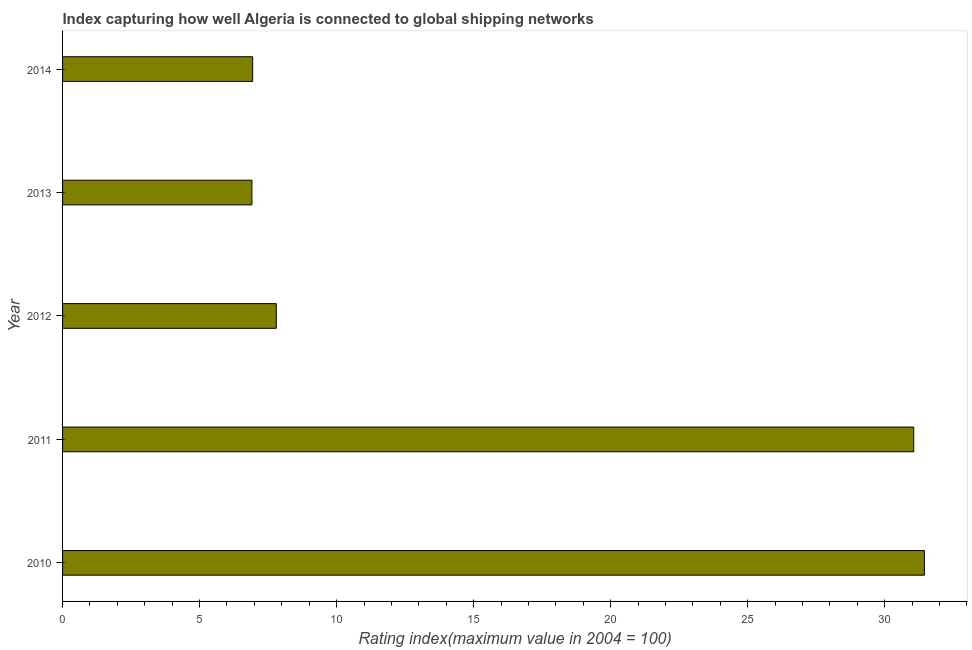Does the graph contain grids?
Your answer should be compact. No. What is the title of the graph?
Keep it short and to the point. Index capturing how well Algeria is connected to global shipping networks. What is the label or title of the X-axis?
Provide a short and direct response. Rating index(maximum value in 2004 = 100). What is the label or title of the Y-axis?
Your answer should be very brief. Year. What is the liner shipping connectivity index in 2011?
Ensure brevity in your answer.  31.06. Across all years, what is the maximum liner shipping connectivity index?
Provide a succinct answer. 31.45. Across all years, what is the minimum liner shipping connectivity index?
Give a very brief answer. 6.91. In which year was the liner shipping connectivity index minimum?
Your response must be concise. 2013. What is the sum of the liner shipping connectivity index?
Provide a short and direct response. 84.16. What is the difference between the liner shipping connectivity index in 2012 and 2013?
Your answer should be compact. 0.89. What is the average liner shipping connectivity index per year?
Your answer should be compact. 16.83. In how many years, is the liner shipping connectivity index greater than 30 ?
Offer a very short reply. 2. What is the ratio of the liner shipping connectivity index in 2012 to that in 2013?
Ensure brevity in your answer.  1.13. What is the difference between the highest and the second highest liner shipping connectivity index?
Keep it short and to the point. 0.39. Is the sum of the liner shipping connectivity index in 2012 and 2013 greater than the maximum liner shipping connectivity index across all years?
Provide a succinct answer. No. What is the difference between the highest and the lowest liner shipping connectivity index?
Your response must be concise. 24.54. In how many years, is the liner shipping connectivity index greater than the average liner shipping connectivity index taken over all years?
Ensure brevity in your answer.  2. How many bars are there?
Your response must be concise. 5. Are all the bars in the graph horizontal?
Ensure brevity in your answer.  Yes. Are the values on the major ticks of X-axis written in scientific E-notation?
Offer a very short reply. No. What is the Rating index(maximum value in 2004 = 100) of 2010?
Provide a succinct answer. 31.45. What is the Rating index(maximum value in 2004 = 100) in 2011?
Provide a short and direct response. 31.06. What is the Rating index(maximum value in 2004 = 100) in 2013?
Keep it short and to the point. 6.91. What is the Rating index(maximum value in 2004 = 100) in 2014?
Your response must be concise. 6.94. What is the difference between the Rating index(maximum value in 2004 = 100) in 2010 and 2011?
Your response must be concise. 0.39. What is the difference between the Rating index(maximum value in 2004 = 100) in 2010 and 2012?
Ensure brevity in your answer.  23.65. What is the difference between the Rating index(maximum value in 2004 = 100) in 2010 and 2013?
Offer a very short reply. 24.54. What is the difference between the Rating index(maximum value in 2004 = 100) in 2010 and 2014?
Offer a terse response. 24.51. What is the difference between the Rating index(maximum value in 2004 = 100) in 2011 and 2012?
Your answer should be compact. 23.26. What is the difference between the Rating index(maximum value in 2004 = 100) in 2011 and 2013?
Give a very brief answer. 24.15. What is the difference between the Rating index(maximum value in 2004 = 100) in 2011 and 2014?
Your answer should be very brief. 24.12. What is the difference between the Rating index(maximum value in 2004 = 100) in 2012 and 2013?
Your answer should be compact. 0.89. What is the difference between the Rating index(maximum value in 2004 = 100) in 2012 and 2014?
Your answer should be compact. 0.86. What is the difference between the Rating index(maximum value in 2004 = 100) in 2013 and 2014?
Ensure brevity in your answer.  -0.03. What is the ratio of the Rating index(maximum value in 2004 = 100) in 2010 to that in 2011?
Your response must be concise. 1.01. What is the ratio of the Rating index(maximum value in 2004 = 100) in 2010 to that in 2012?
Your answer should be compact. 4.03. What is the ratio of the Rating index(maximum value in 2004 = 100) in 2010 to that in 2013?
Give a very brief answer. 4.55. What is the ratio of the Rating index(maximum value in 2004 = 100) in 2010 to that in 2014?
Offer a very short reply. 4.53. What is the ratio of the Rating index(maximum value in 2004 = 100) in 2011 to that in 2012?
Provide a succinct answer. 3.98. What is the ratio of the Rating index(maximum value in 2004 = 100) in 2011 to that in 2013?
Your answer should be very brief. 4.5. What is the ratio of the Rating index(maximum value in 2004 = 100) in 2011 to that in 2014?
Give a very brief answer. 4.48. What is the ratio of the Rating index(maximum value in 2004 = 100) in 2012 to that in 2013?
Your response must be concise. 1.13. What is the ratio of the Rating index(maximum value in 2004 = 100) in 2012 to that in 2014?
Your answer should be compact. 1.12. 